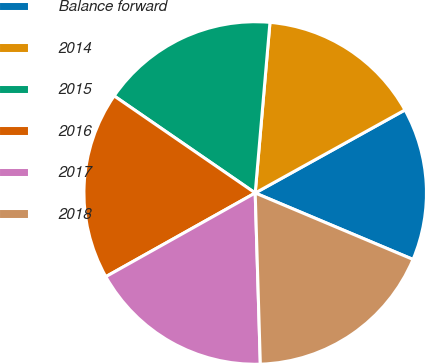Convert chart. <chart><loc_0><loc_0><loc_500><loc_500><pie_chart><fcel>Balance forward<fcel>2014<fcel>2015<fcel>2016<fcel>2017<fcel>2018<nl><fcel>14.4%<fcel>15.57%<fcel>16.78%<fcel>17.72%<fcel>17.35%<fcel>18.18%<nl></chart> 